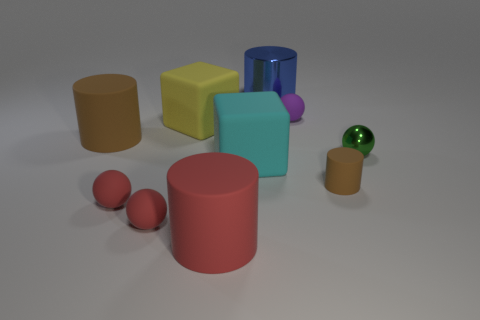What number of other things are the same color as the tiny rubber cylinder?
Provide a succinct answer. 1. What is the shape of the tiny metallic object?
Make the answer very short. Sphere. What color is the tiny object that is behind the matte cylinder that is behind the tiny green shiny object?
Provide a short and direct response. Purple. Does the metallic sphere have the same color as the rubber object that is on the right side of the purple ball?
Your answer should be compact. No. There is a big cylinder that is both behind the tiny rubber cylinder and in front of the yellow object; what is its material?
Offer a very short reply. Rubber. Are there any purple matte things that have the same size as the green object?
Offer a very short reply. Yes. There is a cyan thing that is the same size as the blue thing; what is it made of?
Your response must be concise. Rubber. There is a small rubber cylinder; what number of big red matte cylinders are on the left side of it?
Provide a short and direct response. 1. There is a metallic object in front of the blue thing; does it have the same shape as the tiny purple rubber thing?
Keep it short and to the point. Yes. Are there any big cyan objects that have the same shape as the yellow matte thing?
Provide a short and direct response. Yes. 